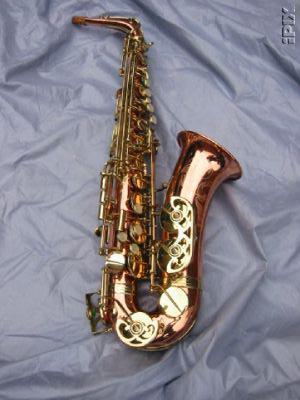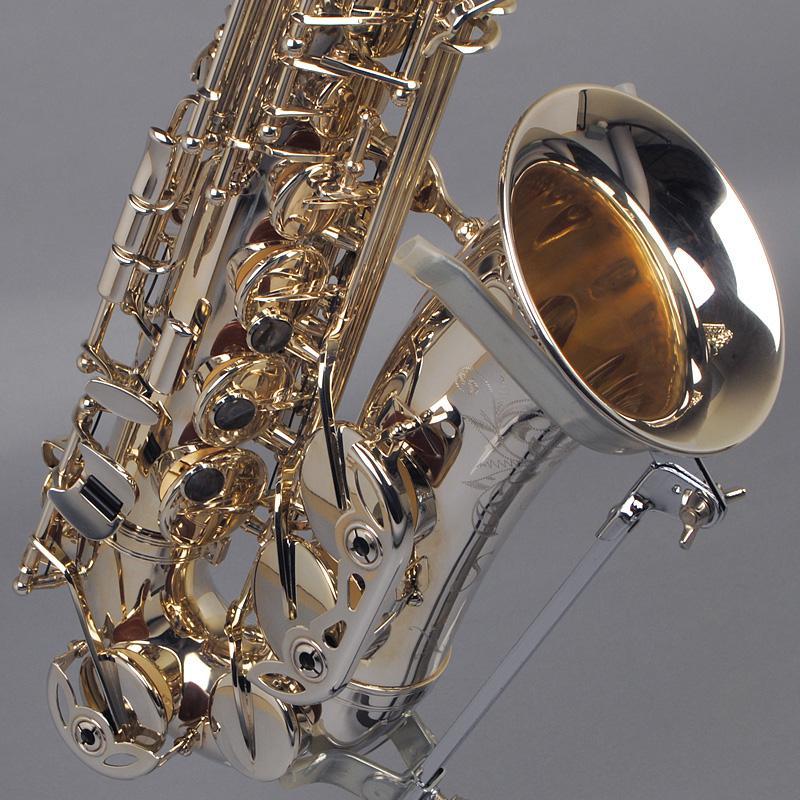The first image is the image on the left, the second image is the image on the right. Evaluate the accuracy of this statement regarding the images: "An image includes a saxophone displayed on a black stand.". Is it true? Answer yes or no. No. The first image is the image on the left, the second image is the image on the right. For the images displayed, is the sentence "Both saxes are being positioned to face the same way." factually correct? Answer yes or no. Yes. 